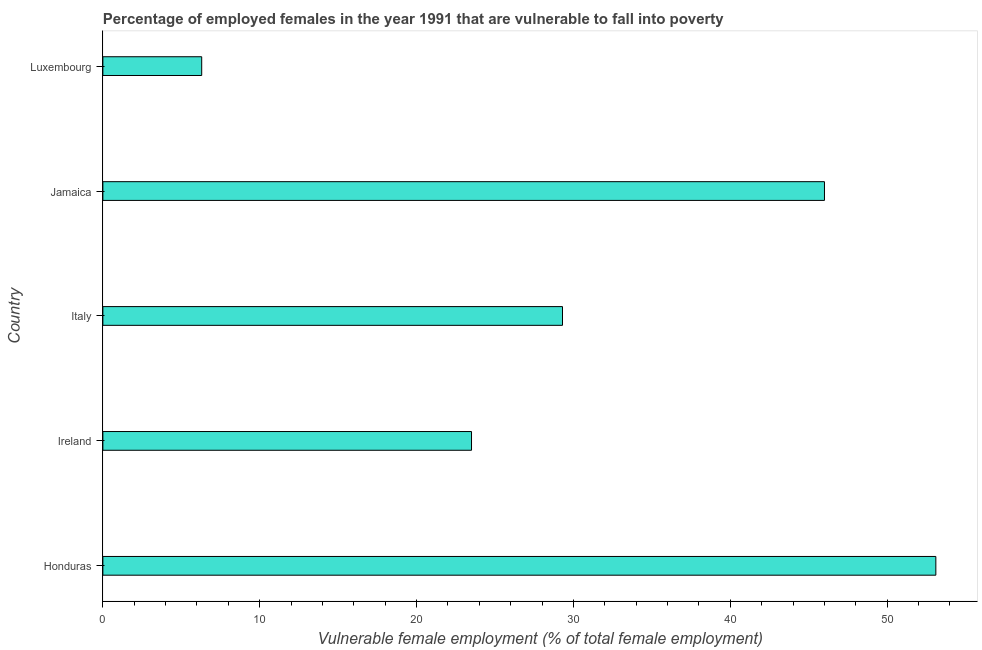Does the graph contain any zero values?
Give a very brief answer. No. Does the graph contain grids?
Ensure brevity in your answer.  No. What is the title of the graph?
Ensure brevity in your answer.  Percentage of employed females in the year 1991 that are vulnerable to fall into poverty. What is the label or title of the X-axis?
Your response must be concise. Vulnerable female employment (% of total female employment). What is the percentage of employed females who are vulnerable to fall into poverty in Italy?
Your answer should be compact. 29.3. Across all countries, what is the maximum percentage of employed females who are vulnerable to fall into poverty?
Ensure brevity in your answer.  53.1. Across all countries, what is the minimum percentage of employed females who are vulnerable to fall into poverty?
Make the answer very short. 6.3. In which country was the percentage of employed females who are vulnerable to fall into poverty maximum?
Your answer should be compact. Honduras. In which country was the percentage of employed females who are vulnerable to fall into poverty minimum?
Offer a terse response. Luxembourg. What is the sum of the percentage of employed females who are vulnerable to fall into poverty?
Provide a short and direct response. 158.2. What is the difference between the percentage of employed females who are vulnerable to fall into poverty in Ireland and Italy?
Your response must be concise. -5.8. What is the average percentage of employed females who are vulnerable to fall into poverty per country?
Give a very brief answer. 31.64. What is the median percentage of employed females who are vulnerable to fall into poverty?
Ensure brevity in your answer.  29.3. In how many countries, is the percentage of employed females who are vulnerable to fall into poverty greater than 16 %?
Offer a terse response. 4. What is the ratio of the percentage of employed females who are vulnerable to fall into poverty in Ireland to that in Luxembourg?
Your answer should be very brief. 3.73. Is the difference between the percentage of employed females who are vulnerable to fall into poverty in Italy and Luxembourg greater than the difference between any two countries?
Give a very brief answer. No. What is the difference between the highest and the lowest percentage of employed females who are vulnerable to fall into poverty?
Ensure brevity in your answer.  46.8. In how many countries, is the percentage of employed females who are vulnerable to fall into poverty greater than the average percentage of employed females who are vulnerable to fall into poverty taken over all countries?
Your answer should be compact. 2. Are all the bars in the graph horizontal?
Offer a terse response. Yes. How many countries are there in the graph?
Make the answer very short. 5. What is the Vulnerable female employment (% of total female employment) in Honduras?
Provide a succinct answer. 53.1. What is the Vulnerable female employment (% of total female employment) in Ireland?
Make the answer very short. 23.5. What is the Vulnerable female employment (% of total female employment) in Italy?
Your response must be concise. 29.3. What is the Vulnerable female employment (% of total female employment) in Luxembourg?
Make the answer very short. 6.3. What is the difference between the Vulnerable female employment (% of total female employment) in Honduras and Ireland?
Ensure brevity in your answer.  29.6. What is the difference between the Vulnerable female employment (% of total female employment) in Honduras and Italy?
Your response must be concise. 23.8. What is the difference between the Vulnerable female employment (% of total female employment) in Honduras and Luxembourg?
Give a very brief answer. 46.8. What is the difference between the Vulnerable female employment (% of total female employment) in Ireland and Italy?
Make the answer very short. -5.8. What is the difference between the Vulnerable female employment (% of total female employment) in Ireland and Jamaica?
Provide a succinct answer. -22.5. What is the difference between the Vulnerable female employment (% of total female employment) in Ireland and Luxembourg?
Your answer should be very brief. 17.2. What is the difference between the Vulnerable female employment (% of total female employment) in Italy and Jamaica?
Your answer should be very brief. -16.7. What is the difference between the Vulnerable female employment (% of total female employment) in Jamaica and Luxembourg?
Your answer should be very brief. 39.7. What is the ratio of the Vulnerable female employment (% of total female employment) in Honduras to that in Ireland?
Offer a very short reply. 2.26. What is the ratio of the Vulnerable female employment (% of total female employment) in Honduras to that in Italy?
Offer a very short reply. 1.81. What is the ratio of the Vulnerable female employment (% of total female employment) in Honduras to that in Jamaica?
Your response must be concise. 1.15. What is the ratio of the Vulnerable female employment (% of total female employment) in Honduras to that in Luxembourg?
Keep it short and to the point. 8.43. What is the ratio of the Vulnerable female employment (% of total female employment) in Ireland to that in Italy?
Provide a short and direct response. 0.8. What is the ratio of the Vulnerable female employment (% of total female employment) in Ireland to that in Jamaica?
Provide a short and direct response. 0.51. What is the ratio of the Vulnerable female employment (% of total female employment) in Ireland to that in Luxembourg?
Provide a succinct answer. 3.73. What is the ratio of the Vulnerable female employment (% of total female employment) in Italy to that in Jamaica?
Give a very brief answer. 0.64. What is the ratio of the Vulnerable female employment (% of total female employment) in Italy to that in Luxembourg?
Your response must be concise. 4.65. What is the ratio of the Vulnerable female employment (% of total female employment) in Jamaica to that in Luxembourg?
Provide a short and direct response. 7.3. 